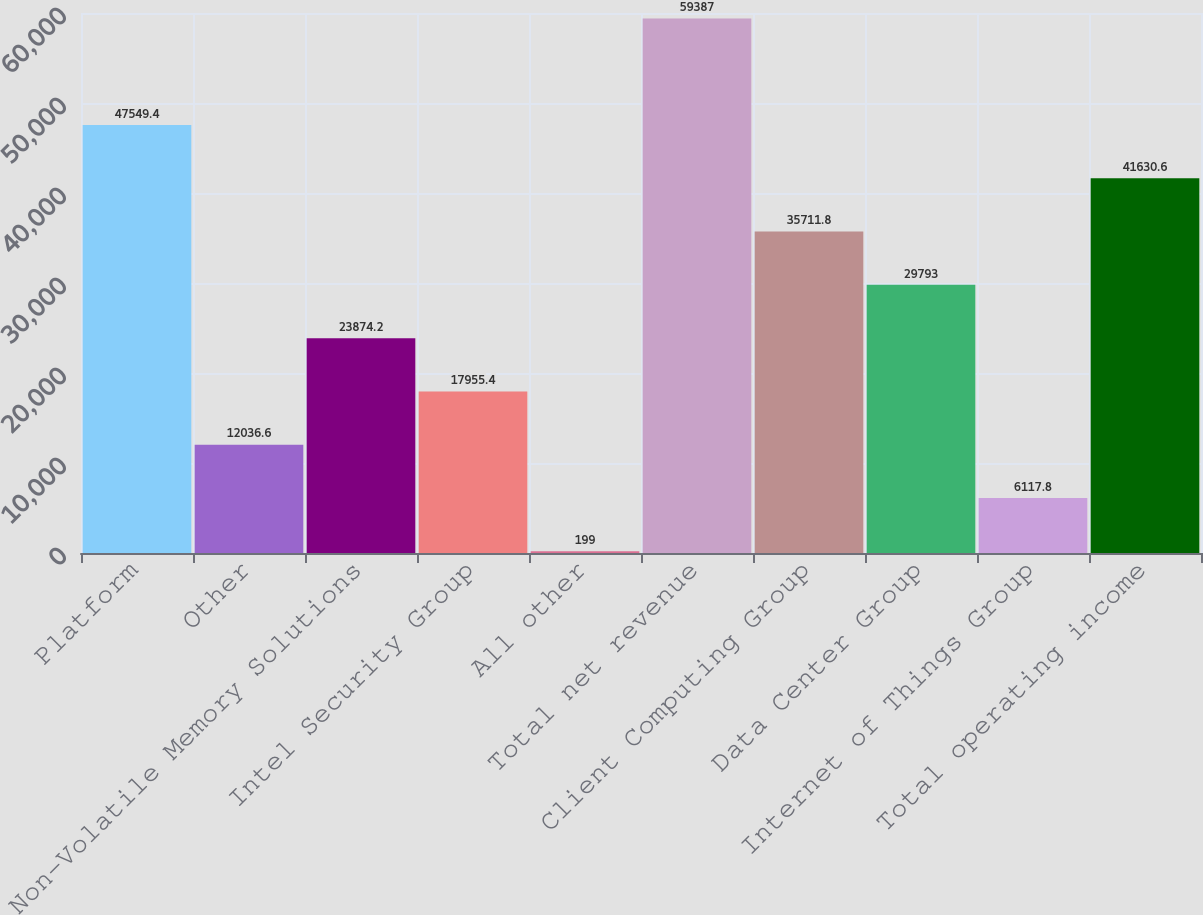Convert chart to OTSL. <chart><loc_0><loc_0><loc_500><loc_500><bar_chart><fcel>Platform<fcel>Other<fcel>Non-Volatile Memory Solutions<fcel>Intel Security Group<fcel>All other<fcel>Total net revenue<fcel>Client Computing Group<fcel>Data Center Group<fcel>Internet of Things Group<fcel>Total operating income<nl><fcel>47549.4<fcel>12036.6<fcel>23874.2<fcel>17955.4<fcel>199<fcel>59387<fcel>35711.8<fcel>29793<fcel>6117.8<fcel>41630.6<nl></chart> 